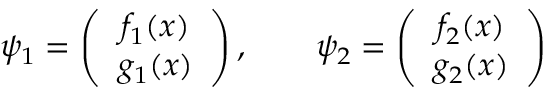Convert formula to latex. <formula><loc_0><loc_0><loc_500><loc_500>\psi _ { 1 } = \left ( \begin{array} { c } { { f _ { 1 } ( x ) } } \\ { { g _ { 1 } ( x ) } } \end{array} \right ) , \quad \psi _ { 2 } = \left ( \begin{array} { c } { { f _ { 2 } ( x ) } } \\ { { g _ { 2 } ( x ) } } \end{array} \right )</formula> 